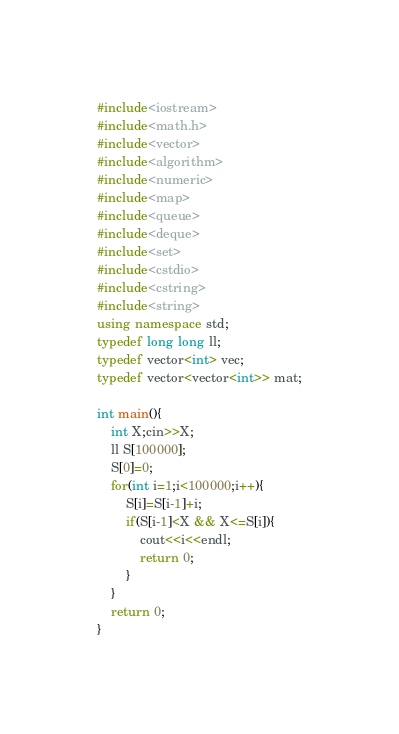Convert code to text. <code><loc_0><loc_0><loc_500><loc_500><_C++_>#include<iostream>
#include<math.h>
#include<vector>
#include<algorithm>
#include<numeric>
#include<map>
#include<queue>
#include<deque>
#include<set>
#include<cstdio>
#include<cstring>
#include<string>
using namespace std;
typedef long long ll;
typedef vector<int> vec;
typedef vector<vector<int>> mat;

int main(){
    int X;cin>>X;
    ll S[100000];
    S[0]=0;
    for(int i=1;i<100000;i++){
        S[i]=S[i-1]+i;
        if(S[i-1]<X && X<=S[i]){
            cout<<i<<endl;
            return 0;
        }
    }
    return 0;
}</code> 